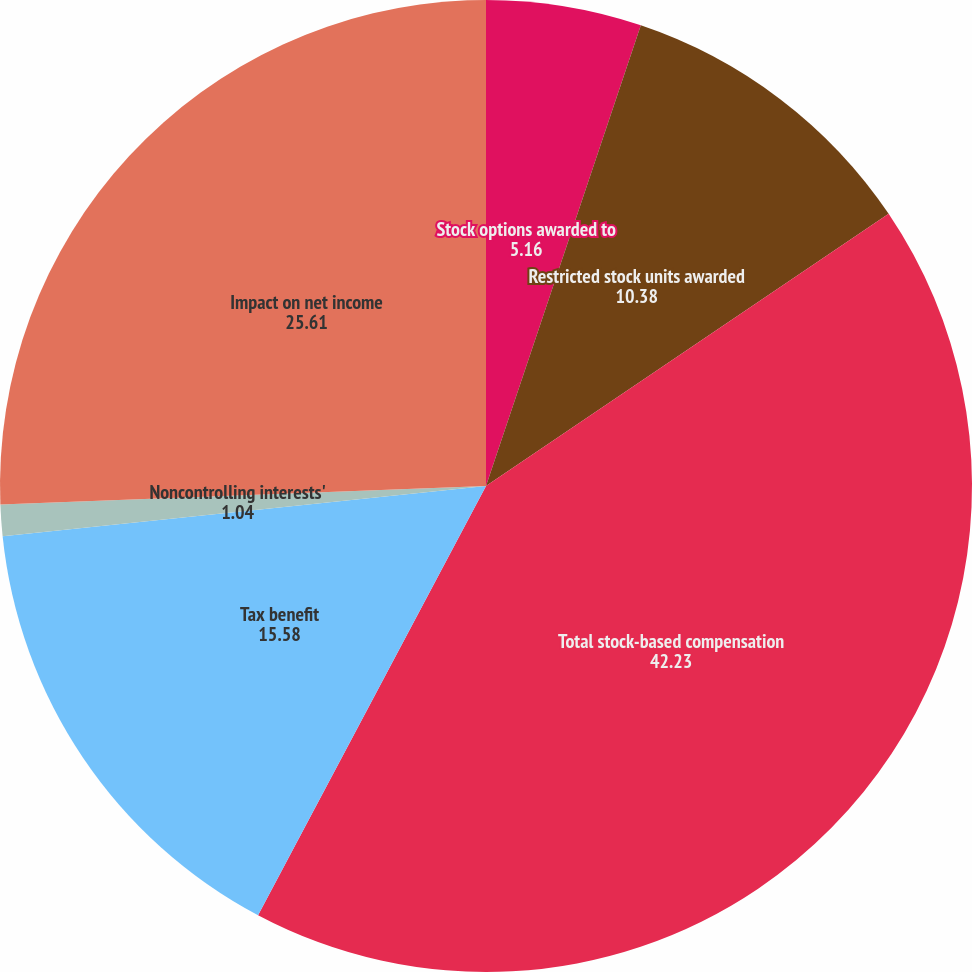Convert chart to OTSL. <chart><loc_0><loc_0><loc_500><loc_500><pie_chart><fcel>Stock options awarded to<fcel>Restricted stock units awarded<fcel>Total stock-based compensation<fcel>Tax benefit<fcel>Noncontrolling interests'<fcel>Impact on net income<nl><fcel>5.16%<fcel>10.38%<fcel>42.23%<fcel>15.58%<fcel>1.04%<fcel>25.61%<nl></chart> 